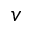<formula> <loc_0><loc_0><loc_500><loc_500>{ v }</formula> 